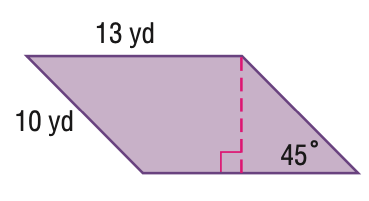Answer the mathemtical geometry problem and directly provide the correct option letter.
Question: Find the perimeter of the parallelogram. Round to the nearest tenth if necessary.
Choices: A: 40 B: 46 C: 52 D: 56 B 